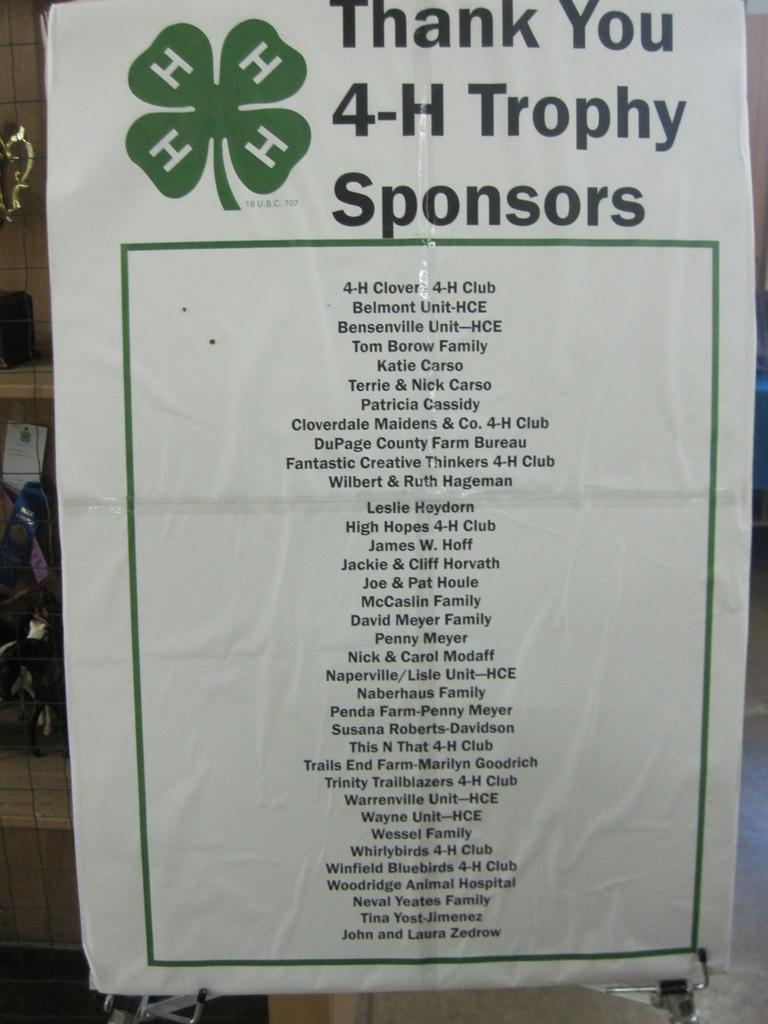What organization is this poster for?
Provide a succinct answer. 4-h. What is this list of?
Make the answer very short. 4-h trophy sponsors. 